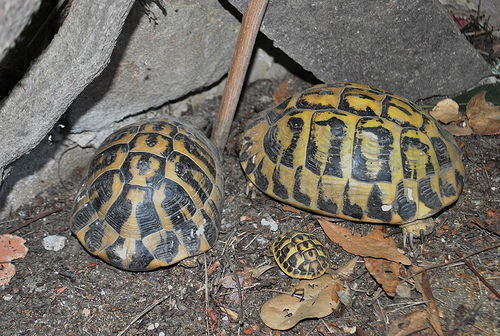<image>
Can you confirm if the tortoise is to the right of the stick? No. The tortoise is not to the right of the stick. The horizontal positioning shows a different relationship. 